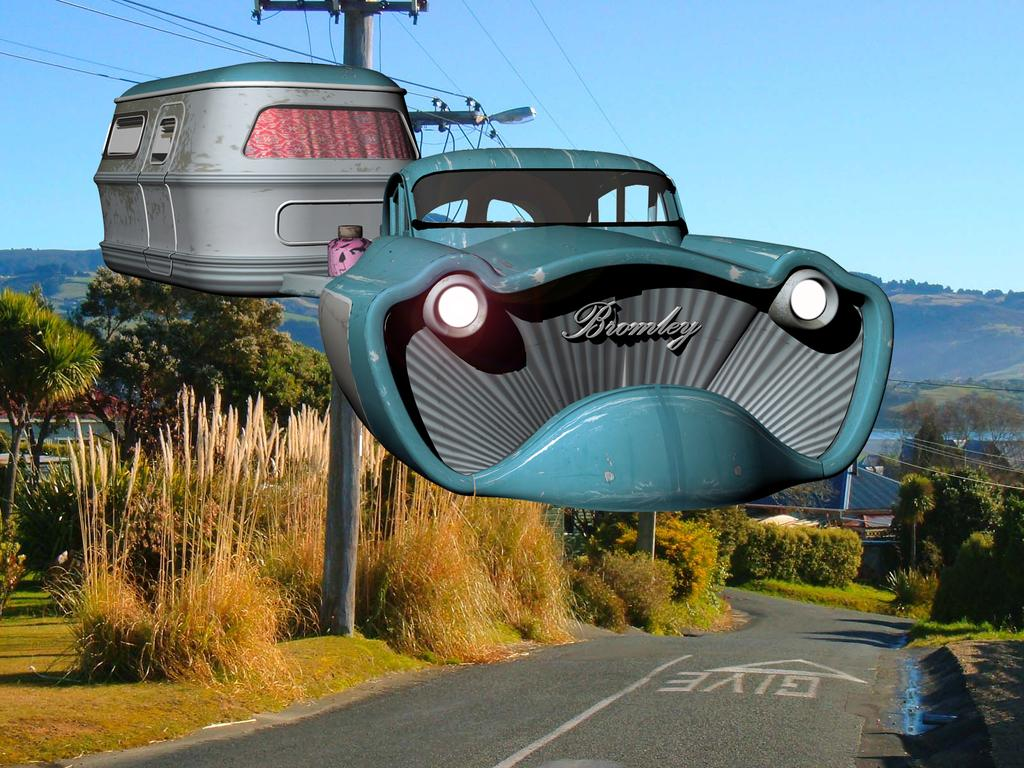What is the main subject of the image? The main subject of the image is a ropeway. What can be seen in the background of the image? There are trees, poles with wires, and hills visible in the background of the image. What is at the bottom of the image? There is a road at the bottom of the image. What type of appliance can be seen in the image? There is no appliance present in the image. How many children are visible in the image? There are no children visible in the image. 